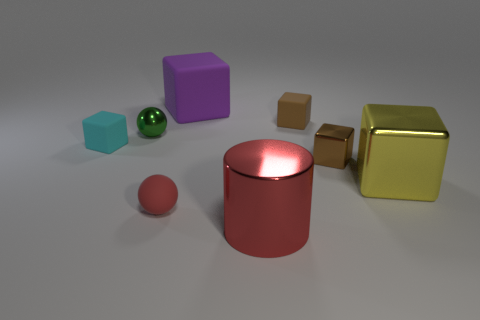There is a matte cube in front of the metal thing left of the large cube behind the green shiny sphere; what color is it?
Your response must be concise. Cyan. There is a shiny cube on the right side of the tiny brown object that is in front of the tiny green shiny thing; what is its size?
Offer a very short reply. Large. What is the material of the block that is both right of the large red metal cylinder and behind the small green metallic object?
Your answer should be very brief. Rubber. There is a cyan rubber block; does it have the same size as the rubber object right of the metal cylinder?
Give a very brief answer. Yes. Is there a large purple block?
Offer a very short reply. Yes. There is a yellow thing that is the same shape as the purple matte thing; what material is it?
Offer a terse response. Metal. What size is the sphere in front of the small matte cube that is to the left of the thing behind the tiny brown rubber block?
Ensure brevity in your answer.  Small. Are there any tiny cyan cubes behind the small cyan rubber object?
Ensure brevity in your answer.  No. What is the size of the ball that is made of the same material as the cylinder?
Your answer should be very brief. Small. What number of small green things have the same shape as the small cyan matte thing?
Your answer should be compact. 0. 